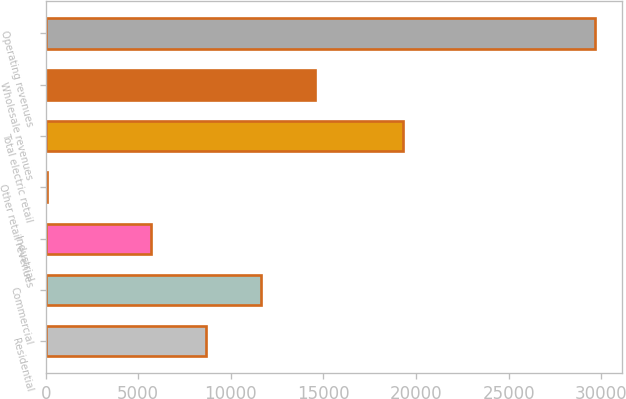Convert chart. <chart><loc_0><loc_0><loc_500><loc_500><bar_chart><fcel>Residential<fcel>Commercial<fcel>Industrial<fcel>Other retail revenues<fcel>Total electric retail<fcel>Wholesale revenues<fcel>Operating revenues<nl><fcel>8645.6<fcel>11602.2<fcel>5689<fcel>73<fcel>19293<fcel>14558.8<fcel>29639<nl></chart> 